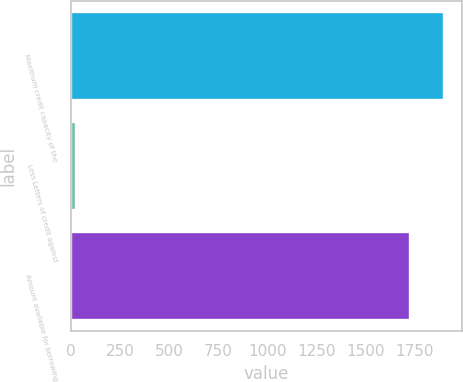Convert chart. <chart><loc_0><loc_0><loc_500><loc_500><bar_chart><fcel>Maximum credit capacity of the<fcel>Less Letters of credit against<fcel>Amount available for borrowing<nl><fcel>1899.7<fcel>23<fcel>1727<nl></chart> 